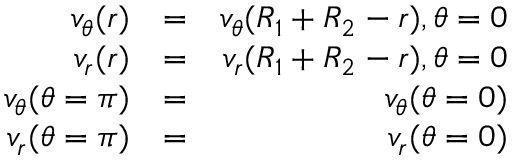<formula> <loc_0><loc_0><loc_500><loc_500>\begin{array} { r l r } { v _ { \theta } ( r ) } & { = } & { v _ { \theta } ( R _ { 1 } + R _ { 2 } - r ) , \theta = 0 } \\ { v _ { r } ( r ) } & { = } & { v _ { r } ( R _ { 1 } + R _ { 2 } - r ) , \theta = 0 } \\ { v _ { \theta } ( \theta = \pi ) } & { = } & { v _ { \theta } ( { \theta = 0 } ) } \\ { v _ { r } ( \theta = \pi ) } & { = } & { v _ { r } ( \theta = 0 ) } \end{array}</formula> 